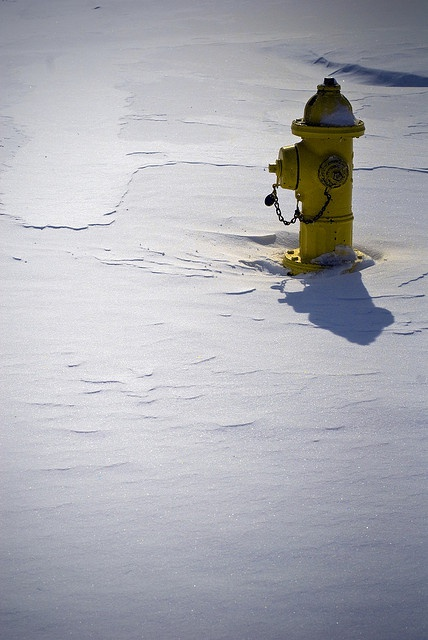Describe the objects in this image and their specific colors. I can see various objects in this image with different colors. 